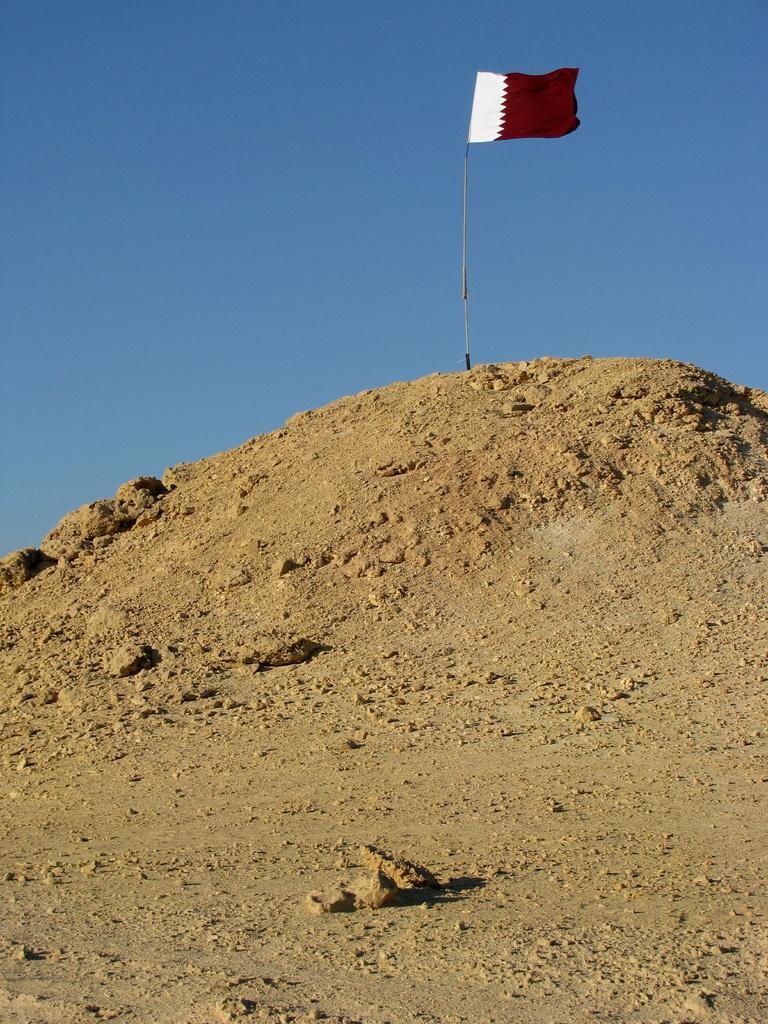Can you describe this image briefly? This picture contains a flag which is in brown and white color. This flag is placed on top of the hill. At the top of the picture, we see the sky, which is blue in color. 